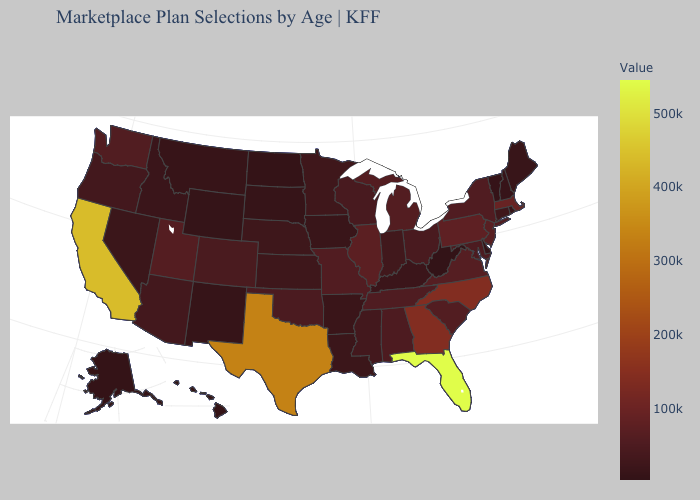Among the states that border Pennsylvania , which have the highest value?
Keep it brief. New Jersey. Among the states that border Oregon , does California have the highest value?
Concise answer only. Yes. Does the map have missing data?
Answer briefly. No. Is the legend a continuous bar?
Quick response, please. Yes. Among the states that border Wyoming , does Montana have the lowest value?
Answer briefly. No. 